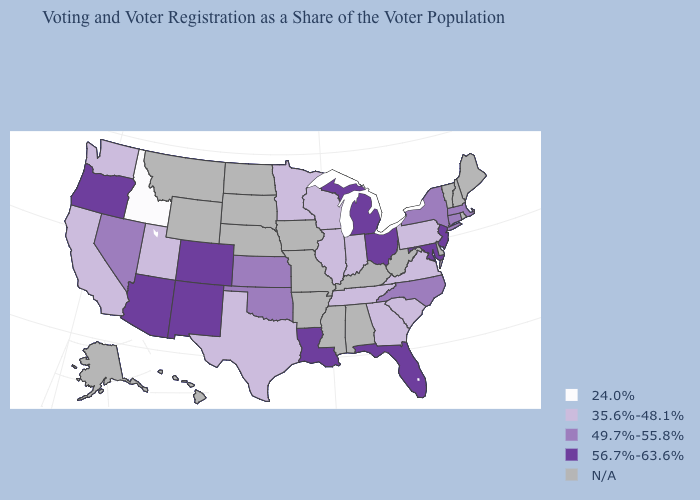What is the value of Rhode Island?
Concise answer only. N/A. Which states have the lowest value in the MidWest?
Be succinct. Illinois, Indiana, Minnesota, Wisconsin. Which states have the lowest value in the USA?
Concise answer only. Idaho. Does Texas have the highest value in the USA?
Write a very short answer. No. Name the states that have a value in the range 35.6%-48.1%?
Short answer required. California, Georgia, Illinois, Indiana, Minnesota, Pennsylvania, South Carolina, Tennessee, Texas, Utah, Virginia, Washington, Wisconsin. Does the map have missing data?
Answer briefly. Yes. Name the states that have a value in the range 24.0%?
Keep it brief. Idaho. Name the states that have a value in the range 35.6%-48.1%?
Give a very brief answer. California, Georgia, Illinois, Indiana, Minnesota, Pennsylvania, South Carolina, Tennessee, Texas, Utah, Virginia, Washington, Wisconsin. Does the first symbol in the legend represent the smallest category?
Answer briefly. Yes. How many symbols are there in the legend?
Concise answer only. 5. What is the value of Kansas?
Write a very short answer. 49.7%-55.8%. Among the states that border Wyoming , does Colorado have the lowest value?
Quick response, please. No. What is the lowest value in the USA?
Give a very brief answer. 24.0%. 